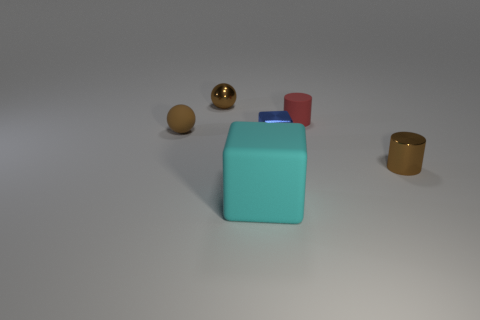Are there any small matte objects that have the same color as the shiny cylinder?
Make the answer very short. Yes. There is a small thing that is both behind the small blue metal object and on the right side of the big cyan matte block; what shape is it?
Provide a succinct answer. Cylinder. The brown object that is right of the brown metal thing that is on the left side of the large cyan matte thing is what shape?
Your response must be concise. Cylinder. Does the brown rubber object have the same shape as the cyan rubber object?
Offer a terse response. No. There is a cylinder that is the same color as the matte sphere; what is it made of?
Offer a terse response. Metal. Is the small rubber sphere the same color as the tiny metallic cylinder?
Give a very brief answer. Yes. There is a tiny brown metal object in front of the small matte object that is on the left side of the red object; what number of tiny things are left of it?
Offer a very short reply. 4. What is the shape of the cyan object that is made of the same material as the red cylinder?
Offer a terse response. Cube. What is the material of the brown sphere that is on the left side of the tiny metal thing behind the blue cube that is to the right of the big matte cube?
Offer a terse response. Rubber. How many things are tiny brown objects that are in front of the brown metal sphere or purple matte cubes?
Give a very brief answer. 2. 